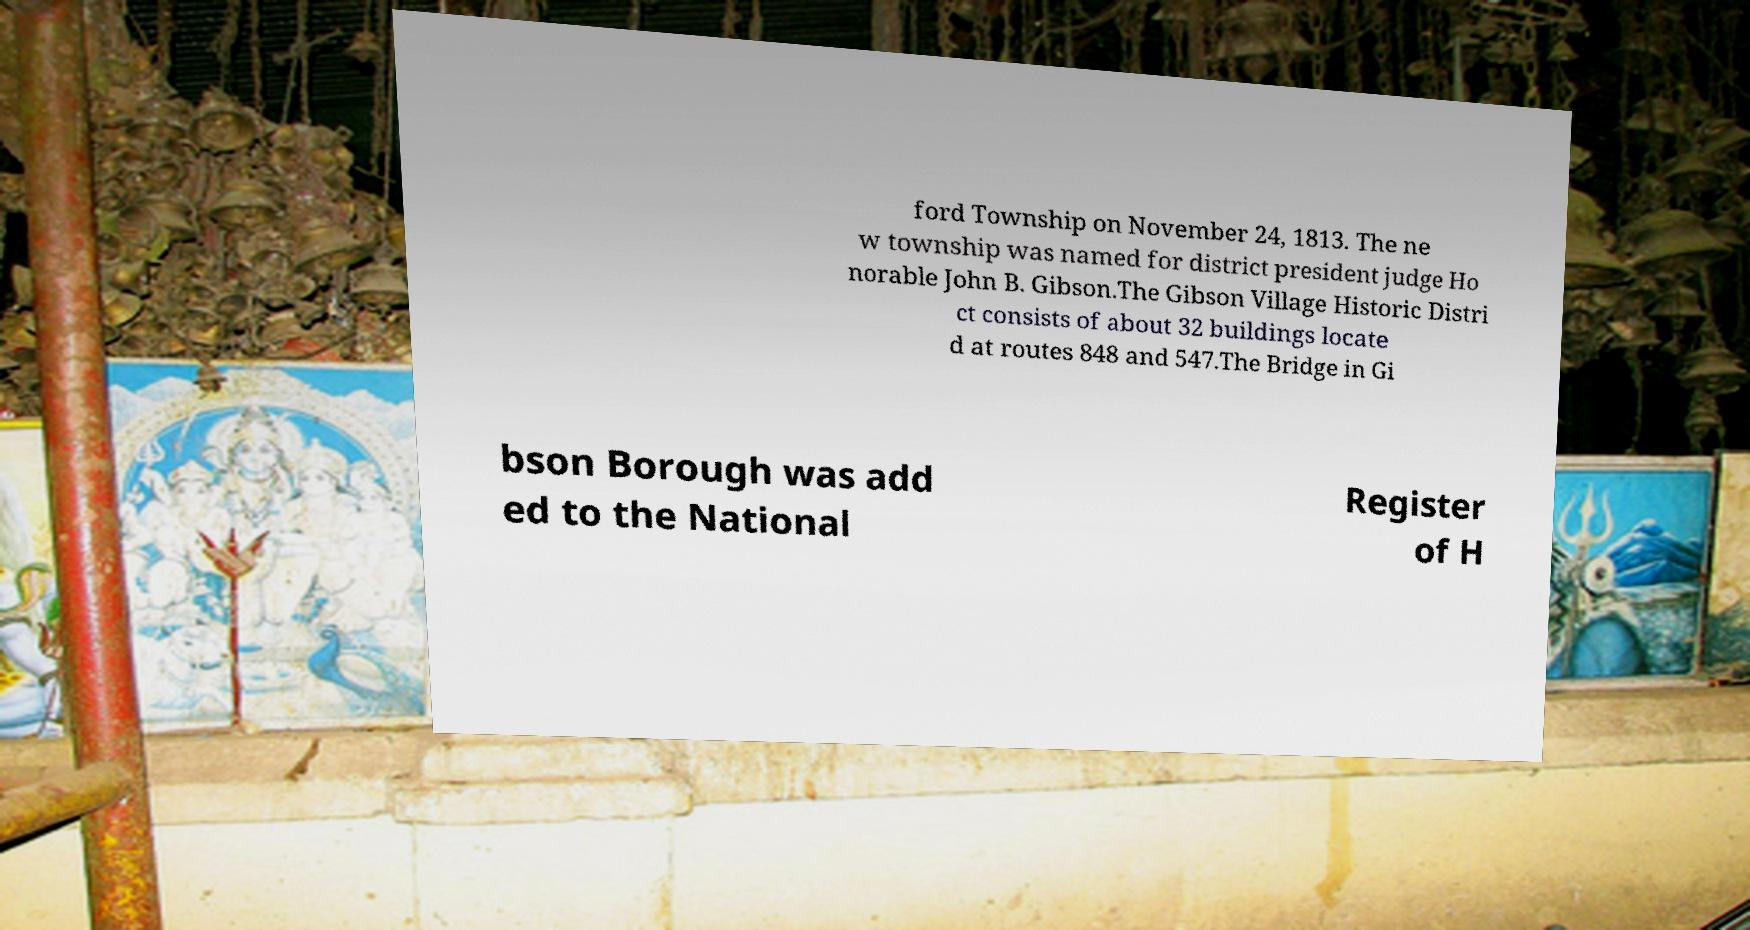Please read and relay the text visible in this image. What does it say? ford Township on November 24, 1813. The ne w township was named for district president judge Ho norable John B. Gibson.The Gibson Village Historic Distri ct consists of about 32 buildings locate d at routes 848 and 547.The Bridge in Gi bson Borough was add ed to the National Register of H 